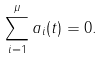<formula> <loc_0><loc_0><loc_500><loc_500>\sum _ { i = 1 } ^ { \mu } a _ { i } ( t ) = 0 .</formula> 